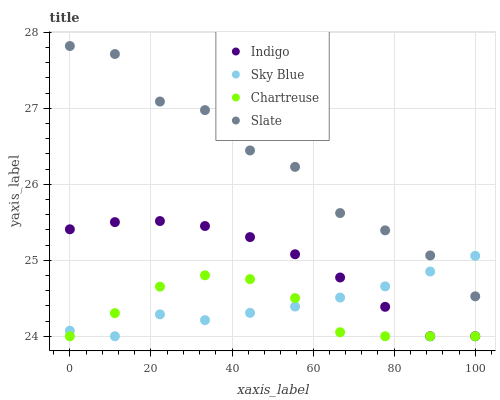Does Chartreuse have the minimum area under the curve?
Answer yes or no. Yes. Does Slate have the maximum area under the curve?
Answer yes or no. Yes. Does Indigo have the minimum area under the curve?
Answer yes or no. No. Does Indigo have the maximum area under the curve?
Answer yes or no. No. Is Indigo the smoothest?
Answer yes or no. Yes. Is Slate the roughest?
Answer yes or no. Yes. Is Chartreuse the smoothest?
Answer yes or no. No. Is Chartreuse the roughest?
Answer yes or no. No. Does Sky Blue have the lowest value?
Answer yes or no. Yes. Does Slate have the lowest value?
Answer yes or no. No. Does Slate have the highest value?
Answer yes or no. Yes. Does Indigo have the highest value?
Answer yes or no. No. Is Chartreuse less than Slate?
Answer yes or no. Yes. Is Slate greater than Indigo?
Answer yes or no. Yes. Does Chartreuse intersect Sky Blue?
Answer yes or no. Yes. Is Chartreuse less than Sky Blue?
Answer yes or no. No. Is Chartreuse greater than Sky Blue?
Answer yes or no. No. Does Chartreuse intersect Slate?
Answer yes or no. No. 